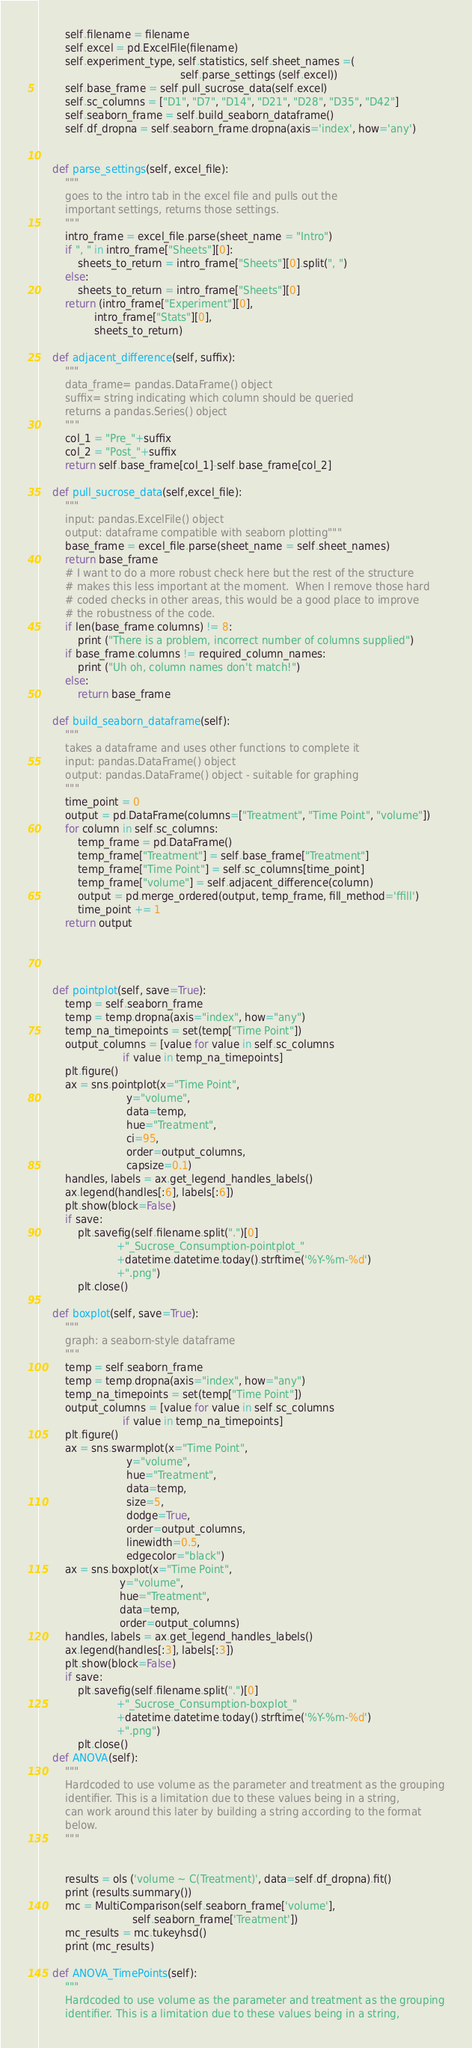Convert code to text. <code><loc_0><loc_0><loc_500><loc_500><_Python_>        self.filename = filename
        self.excel = pd.ExcelFile(filename)
        self.experiment_type, self.statistics, self.sheet_names =(
                                            self.parse_settings (self.excel))
        self.base_frame = self.pull_sucrose_data(self.excel)
        self.sc_columns = ["D1", "D7", "D14", "D21", "D28", "D35", "D42"]
        self.seaborn_frame = self.build_seaborn_dataframe()
        self.df_dropna = self.seaborn_frame.dropna(axis='index', how='any')


    def parse_settings(self, excel_file):
        """
        goes to the intro tab in the excel file and pulls out the
        important settings, returns those settings.
        """
        intro_frame = excel_file.parse(sheet_name = "Intro")
        if ", " in intro_frame["Sheets"][0]:
            sheets_to_return = intro_frame["Sheets"][0].split(", ")
        else:
            sheets_to_return = intro_frame["Sheets"][0]
        return (intro_frame["Experiment"][0],
                 intro_frame["Stats"][0],
                 sheets_to_return)

    def adjacent_difference(self, suffix):
        """
        data_frame= pandas.DataFrame() object
        suffix= string indicating which column should be queried
        returns a pandas.Series() object
        """
        col_1 = "Pre_"+suffix
        col_2 = "Post_"+suffix
        return self.base_frame[col_1]-self.base_frame[col_2]

    def pull_sucrose_data(self,excel_file):
        """
        input: pandas.ExcelFile() object
        output: dataframe compatible with seaborn plotting"""
        base_frame = excel_file.parse(sheet_name = self.sheet_names)
        return base_frame
        # I want to do a more robust check here but the rest of the structure
        # makes this less important at the moment.  When I remove those hard
        # coded checks in other areas, this would be a good place to improve
        # the robustness of the code.
        if len(base_frame.columns) != 8:
            print ("There is a problem, incorrect number of columns supplied")
        if base_frame.columns != required_column_names:
            print ("Uh oh, column names don't match!")
        else:
            return base_frame

    def build_seaborn_dataframe(self):
        """
        takes a dataframe and uses other functions to complete it
        input: pandas.DataFrame() object
        output: pandas.DataFrame() object - suitable for graphing
        """
        time_point = 0
        output = pd.DataFrame(columns=["Treatment", "Time Point", "volume"])
        for column in self.sc_columns:
            temp_frame = pd.DataFrame()
            temp_frame["Treatment"] = self.base_frame["Treatment"]
            temp_frame["Time Point"] = self.sc_columns[time_point]
            temp_frame["volume"] = self.adjacent_difference(column)
            output = pd.merge_ordered(output, temp_frame, fill_method='ffill')
            time_point += 1
        return output




    def pointplot(self, save=True):
        temp = self.seaborn_frame
        temp = temp.dropna(axis="index", how="any")
        temp_na_timepoints = set(temp["Time Point"])
        output_columns = [value for value in self.sc_columns
                          if value in temp_na_timepoints]
        plt.figure()
        ax = sns.pointplot(x="Time Point",
                           y="volume",
                           data=temp,
                           hue="Treatment",
                           ci=95,
                           order=output_columns,
                           capsize=0.1)
        handles, labels = ax.get_legend_handles_labels()
        ax.legend(handles[:6], labels[:6])
        plt.show(block=False)
        if save:
            plt.savefig(self.filename.split(".")[0]
                        +"_Sucrose_Consumption-pointplot_"
                        +datetime.datetime.today().strftime('%Y-%m-%d')
                        +".png")
            plt.close()

    def boxplot(self, save=True):
        """
        graph: a seaborn-style dataframe
        """
        temp = self.seaborn_frame
        temp = temp.dropna(axis="index", how="any")
        temp_na_timepoints = set(temp["Time Point"])
        output_columns = [value for value in self.sc_columns
                          if value in temp_na_timepoints]
        plt.figure()
        ax = sns.swarmplot(x="Time Point",
                           y="volume",
                           hue="Treatment",
                           data=temp,
                           size=5,
                           dodge=True,
                           order=output_columns,
                           linewidth=0.5,
                           edgecolor="black")
        ax = sns.boxplot(x="Time Point",
                         y="volume",
                         hue="Treatment",
                         data=temp,
                         order=output_columns)
        handles, labels = ax.get_legend_handles_labels()
        ax.legend(handles[:3], labels[:3])
        plt.show(block=False)
        if save:
            plt.savefig(self.filename.split(".")[0]
                        +"_Sucrose_Consumption-boxplot_"
                        +datetime.datetime.today().strftime('%Y-%m-%d')
                        +".png")
            plt.close()
    def ANOVA(self):
        """
        Hardcoded to use volume as the parameter and treatment as the grouping
        identifier. This is a limitation due to these values being in a string,
        can work around this later by building a string according to the format
        below.
        """


        results = ols ('volume ~ C(Treatment)', data=self.df_dropna).fit()
        print (results.summary())
        mc = MultiComparison(self.seaborn_frame['volume'],
                             self.seaborn_frame['Treatment'])
        mc_results = mc.tukeyhsd()
        print (mc_results)

    def ANOVA_TimePoints(self):
        """
        Hardcoded to use volume as the parameter and treatment as the grouping
        identifier. This is a limitation due to these values being in a string,</code> 